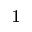<formula> <loc_0><loc_0><loc_500><loc_500>^ { 1 }</formula> 